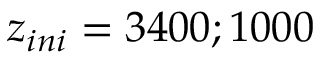Convert formula to latex. <formula><loc_0><loc_0><loc_500><loc_500>z _ { i n i } = 3 4 0 0 ; 1 0 0 0</formula> 